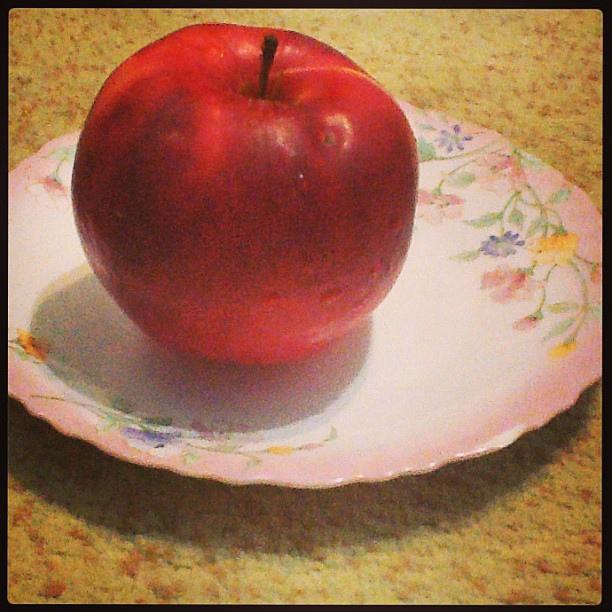Is there a bite out of the apple?
Be succinct. No. Is the fruit on a plate?
Quick response, please. Yes. What type of surface is the plate sitting on?
Short answer required. Carpet. 